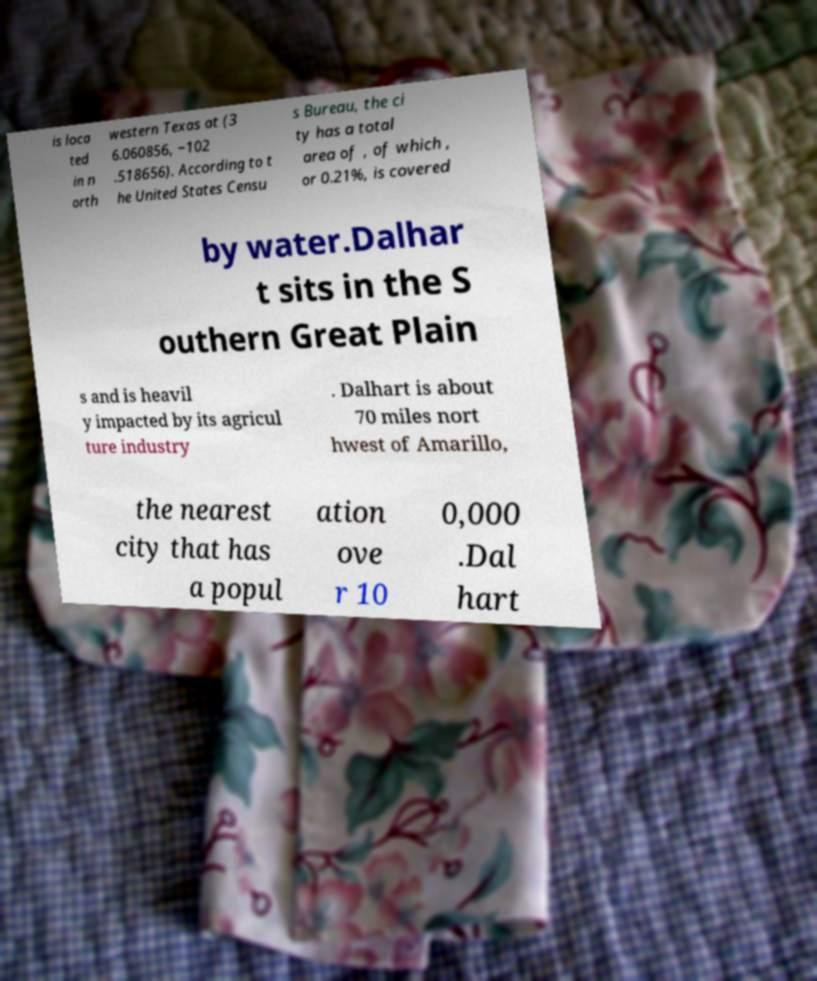Can you accurately transcribe the text from the provided image for me? is loca ted in n orth western Texas at (3 6.060856, −102 .518656). According to t he United States Censu s Bureau, the ci ty has a total area of , of which , or 0.21%, is covered by water.Dalhar t sits in the S outhern Great Plain s and is heavil y impacted by its agricul ture industry . Dalhart is about 70 miles nort hwest of Amarillo, the nearest city that has a popul ation ove r 10 0,000 .Dal hart 